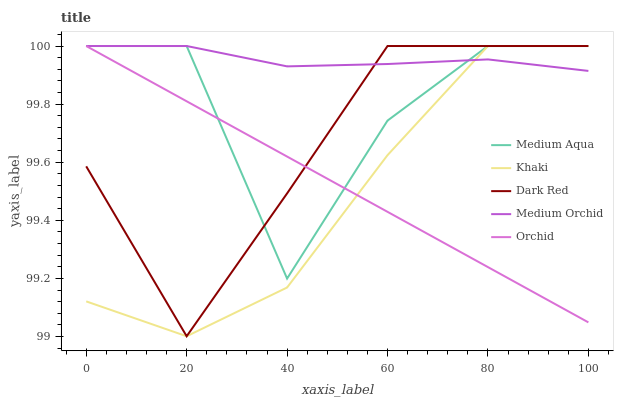Does Khaki have the minimum area under the curve?
Answer yes or no. Yes. Does Medium Orchid have the maximum area under the curve?
Answer yes or no. Yes. Does Medium Orchid have the minimum area under the curve?
Answer yes or no. No. Does Khaki have the maximum area under the curve?
Answer yes or no. No. Is Orchid the smoothest?
Answer yes or no. Yes. Is Medium Aqua the roughest?
Answer yes or no. Yes. Is Medium Orchid the smoothest?
Answer yes or no. No. Is Medium Orchid the roughest?
Answer yes or no. No. Does Khaki have the lowest value?
Answer yes or no. Yes. Does Medium Orchid have the lowest value?
Answer yes or no. No. Does Orchid have the highest value?
Answer yes or no. Yes. Does Dark Red intersect Medium Orchid?
Answer yes or no. Yes. Is Dark Red less than Medium Orchid?
Answer yes or no. No. Is Dark Red greater than Medium Orchid?
Answer yes or no. No. 